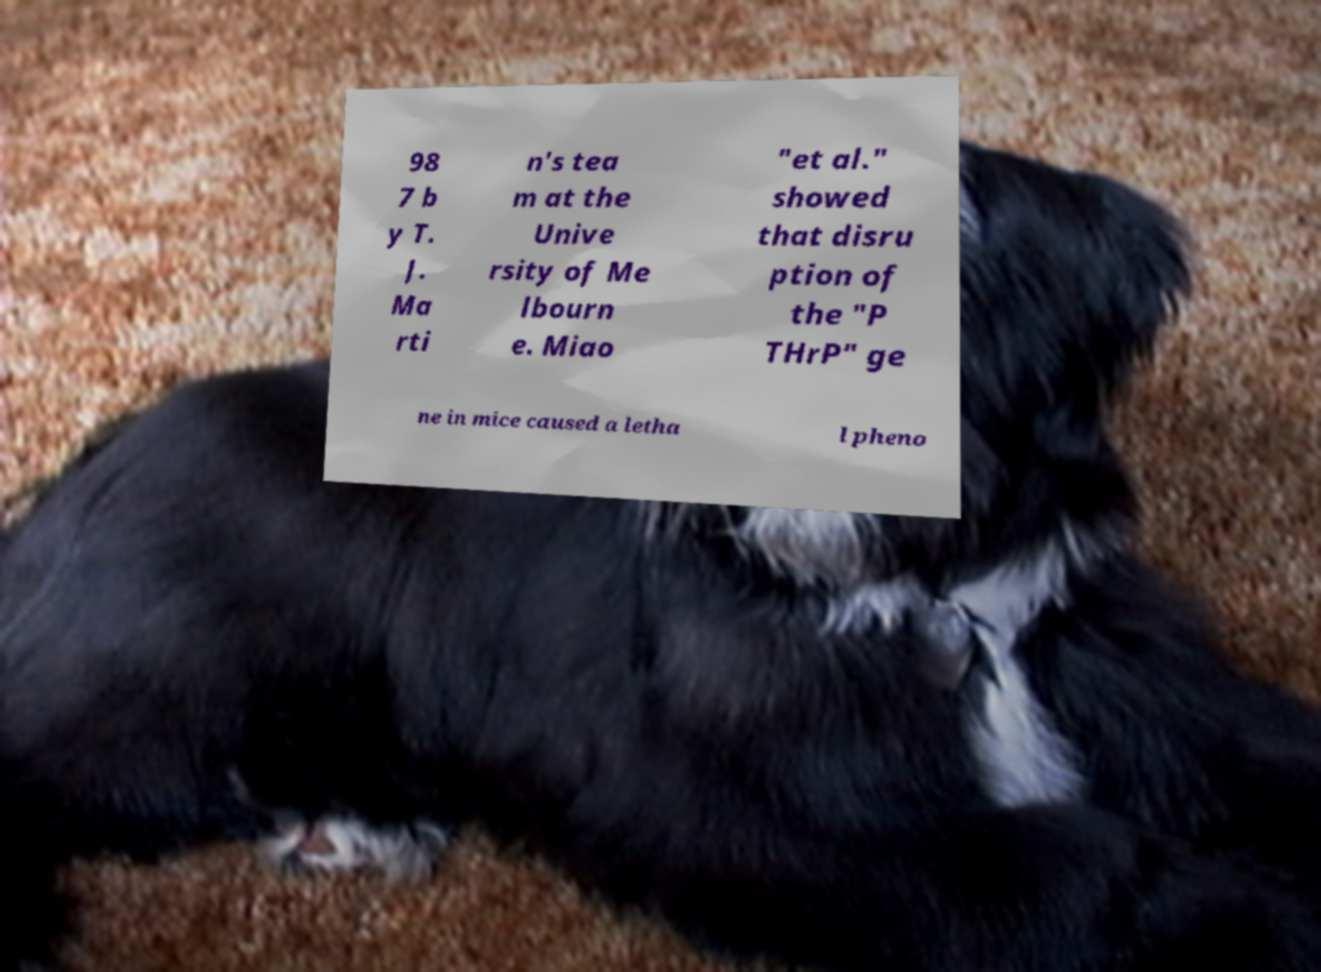Please identify and transcribe the text found in this image. 98 7 b y T. J. Ma rti n's tea m at the Unive rsity of Me lbourn e. Miao "et al." showed that disru ption of the "P THrP" ge ne in mice caused a letha l pheno 